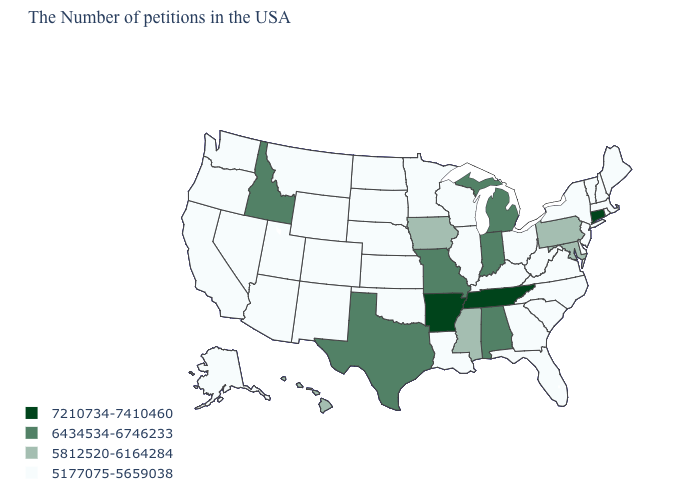Which states have the lowest value in the USA?
Write a very short answer. Maine, Massachusetts, Rhode Island, New Hampshire, Vermont, New York, New Jersey, Delaware, Virginia, North Carolina, South Carolina, West Virginia, Ohio, Florida, Georgia, Kentucky, Wisconsin, Illinois, Louisiana, Minnesota, Kansas, Nebraska, Oklahoma, South Dakota, North Dakota, Wyoming, Colorado, New Mexico, Utah, Montana, Arizona, Nevada, California, Washington, Oregon, Alaska. Name the states that have a value in the range 5812520-6164284?
Concise answer only. Maryland, Pennsylvania, Mississippi, Iowa, Hawaii. What is the value of Maine?
Write a very short answer. 5177075-5659038. Does the first symbol in the legend represent the smallest category?
Quick response, please. No. Is the legend a continuous bar?
Answer briefly. No. Name the states that have a value in the range 6434534-6746233?
Concise answer only. Michigan, Indiana, Alabama, Missouri, Texas, Idaho. What is the lowest value in the USA?
Give a very brief answer. 5177075-5659038. Name the states that have a value in the range 5812520-6164284?
Be succinct. Maryland, Pennsylvania, Mississippi, Iowa, Hawaii. What is the value of Wisconsin?
Answer briefly. 5177075-5659038. Does Idaho have the highest value in the West?
Give a very brief answer. Yes. Among the states that border Missouri , does Arkansas have the highest value?
Answer briefly. Yes. Which states have the lowest value in the MidWest?
Give a very brief answer. Ohio, Wisconsin, Illinois, Minnesota, Kansas, Nebraska, South Dakota, North Dakota. Name the states that have a value in the range 5812520-6164284?
Write a very short answer. Maryland, Pennsylvania, Mississippi, Iowa, Hawaii. What is the highest value in the Northeast ?
Give a very brief answer. 7210734-7410460. Does Illinois have a lower value than Alabama?
Be succinct. Yes. 